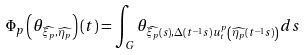Convert formula to latex. <formula><loc_0><loc_0><loc_500><loc_500>\Phi _ { p } \left ( \theta _ { \widehat { \xi _ { p } } , \widehat { \eta _ { p } } } \right ) ( t ) = \int _ { G } \theta _ { \widehat { \xi _ { p } } ( s ) , \Delta ( t ^ { - 1 } s ) u _ { t } ^ { p } \left ( \widehat { \eta _ { p } } ( t ^ { - 1 } s ) \right ) } d s</formula> 